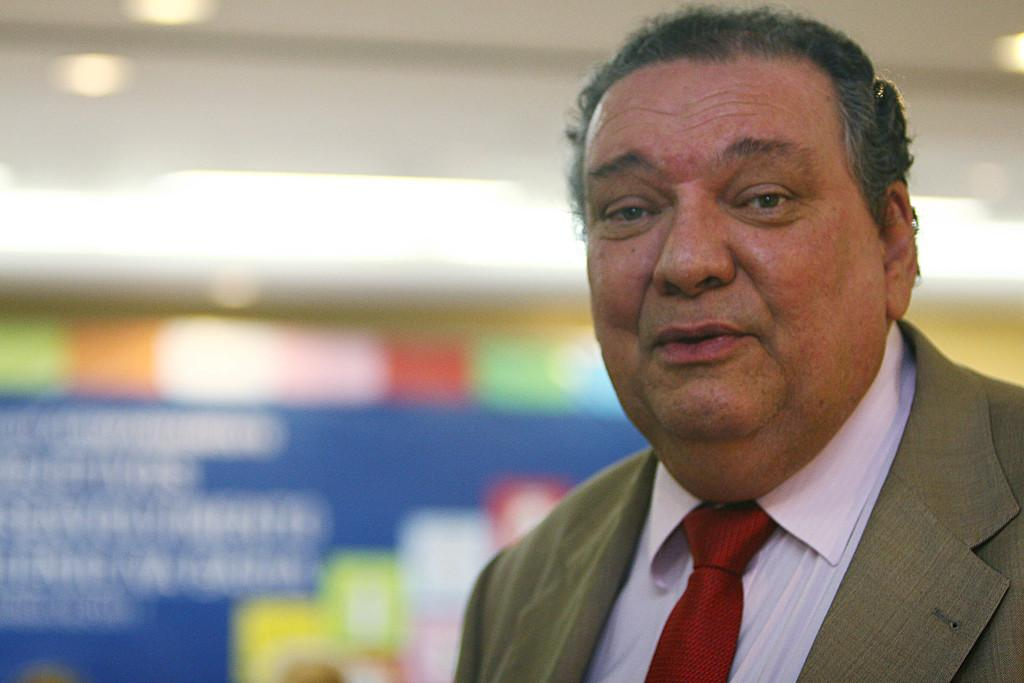What is the main subject of the image? There is a person in the image. What is the person wearing on their upper body? The person is wearing a brown blazer, a white shirt, and a red tie. How would you describe the background of the image? The background of the image is blurred. What rule is being enforced in the scene depicted in the image? There is no scene or rule present in the image; it only features a person wearing a brown blazer, a white shirt, and a red tie with a blurred background. 